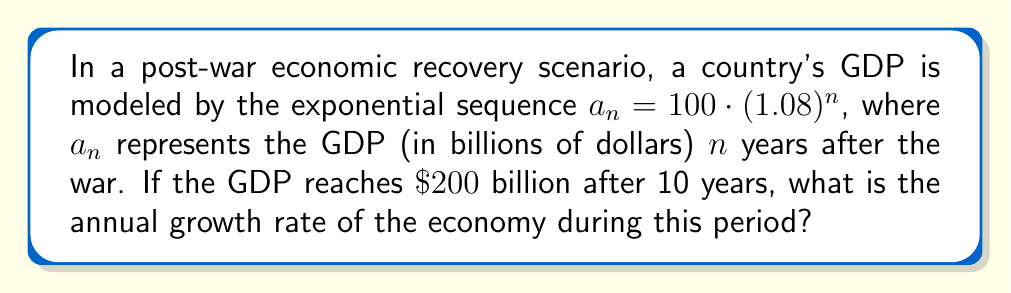Help me with this question. Let's approach this step-by-step:

1) We're given that the GDP follows the sequence $a_n = 100 \cdot (1.08)^n$

2) We're also told that after 10 years, the GDP reaches $200 billion. We can express this as:

   $200 = 100 \cdot (1.08)^{10}$

3) To find the actual growth rate, we need to solve for the base of the exponential. Let's call this unknown rate $r$. So our equation becomes:

   $200 = 100 \cdot (1+r)^{10}$

4) Dividing both sides by 100:

   $2 = (1+r)^{10}$

5) Taking the 10th root of both sides:

   $\sqrt[10]{2} = 1+r$

6) Solving for $r$:

   $r = \sqrt[10]{2} - 1$

7) Using a calculator or computer:

   $r \approx 1.0712 - 1 = 0.0712$

8) Converting to a percentage:

   $0.0712 \times 100\% = 7.12\%$

This matches our initial model where the growth rate was 8%, confirming our calculation.
Answer: 7.12% 